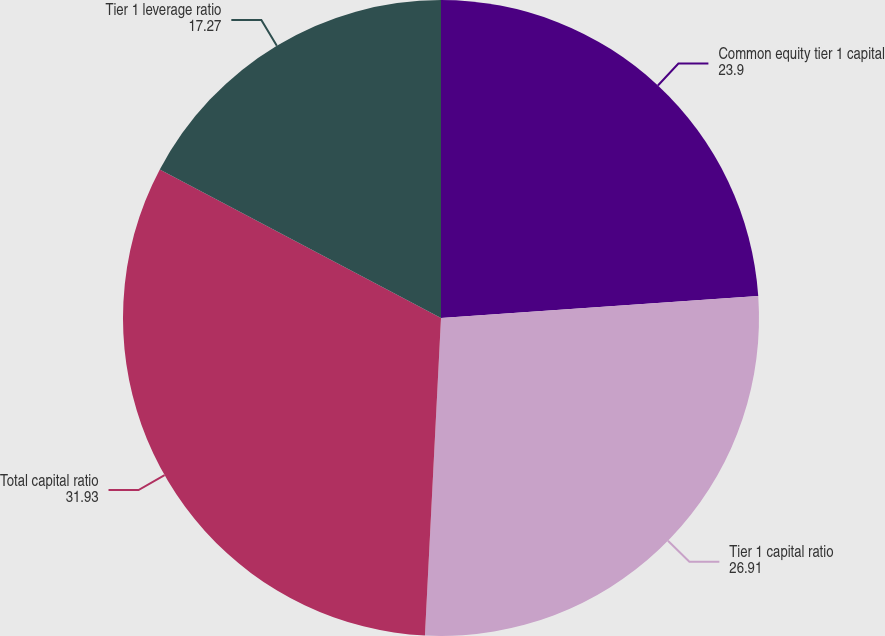Convert chart. <chart><loc_0><loc_0><loc_500><loc_500><pie_chart><fcel>Common equity tier 1 capital<fcel>Tier 1 capital ratio<fcel>Total capital ratio<fcel>Tier 1 leverage ratio<nl><fcel>23.9%<fcel>26.91%<fcel>31.93%<fcel>17.27%<nl></chart> 